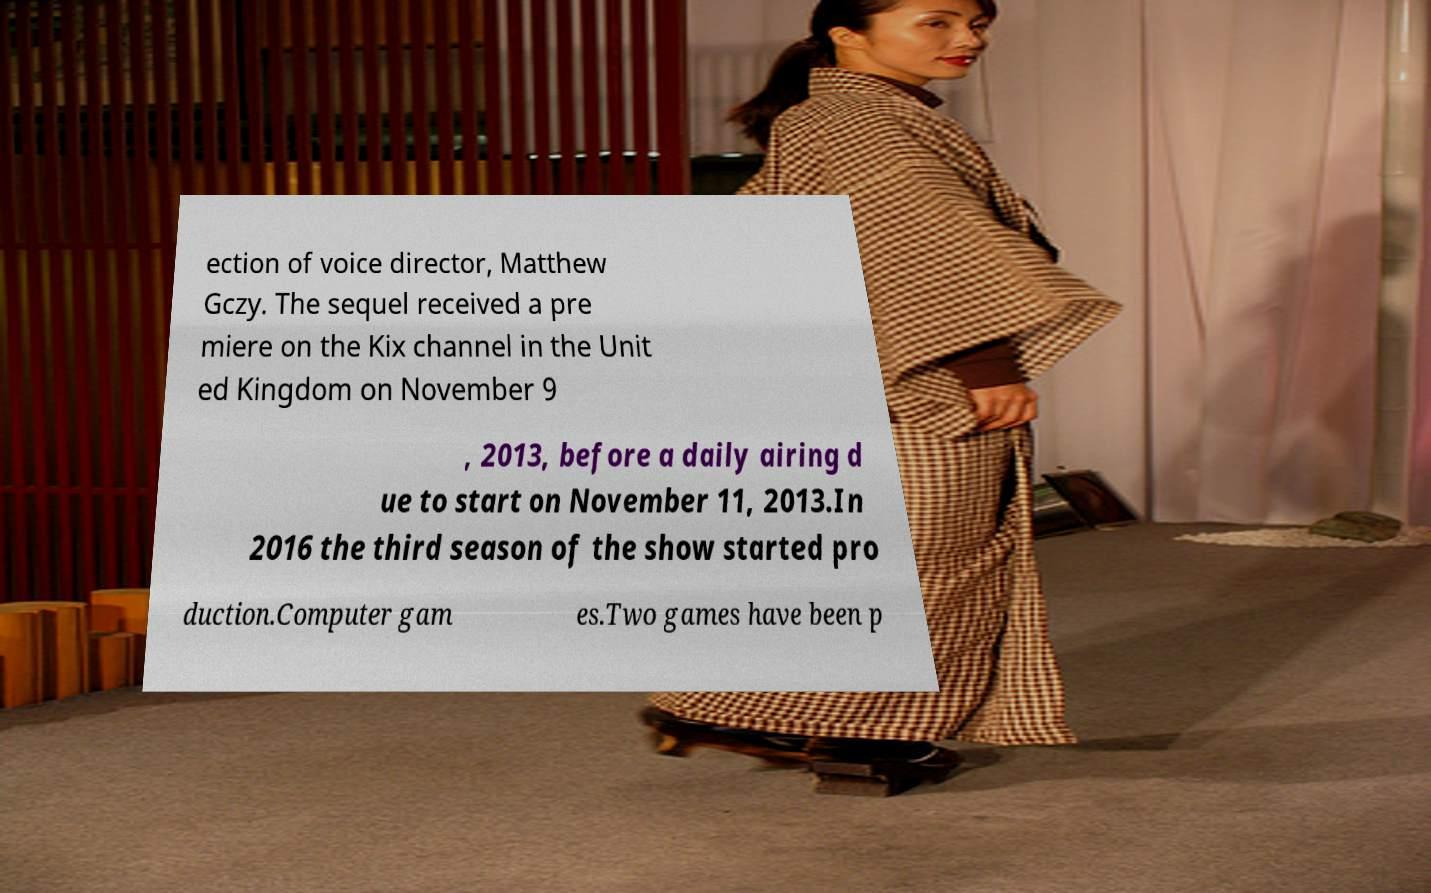Could you assist in decoding the text presented in this image and type it out clearly? ection of voice director, Matthew Gczy. The sequel received a pre miere on the Kix channel in the Unit ed Kingdom on November 9 , 2013, before a daily airing d ue to start on November 11, 2013.In 2016 the third season of the show started pro duction.Computer gam es.Two games have been p 